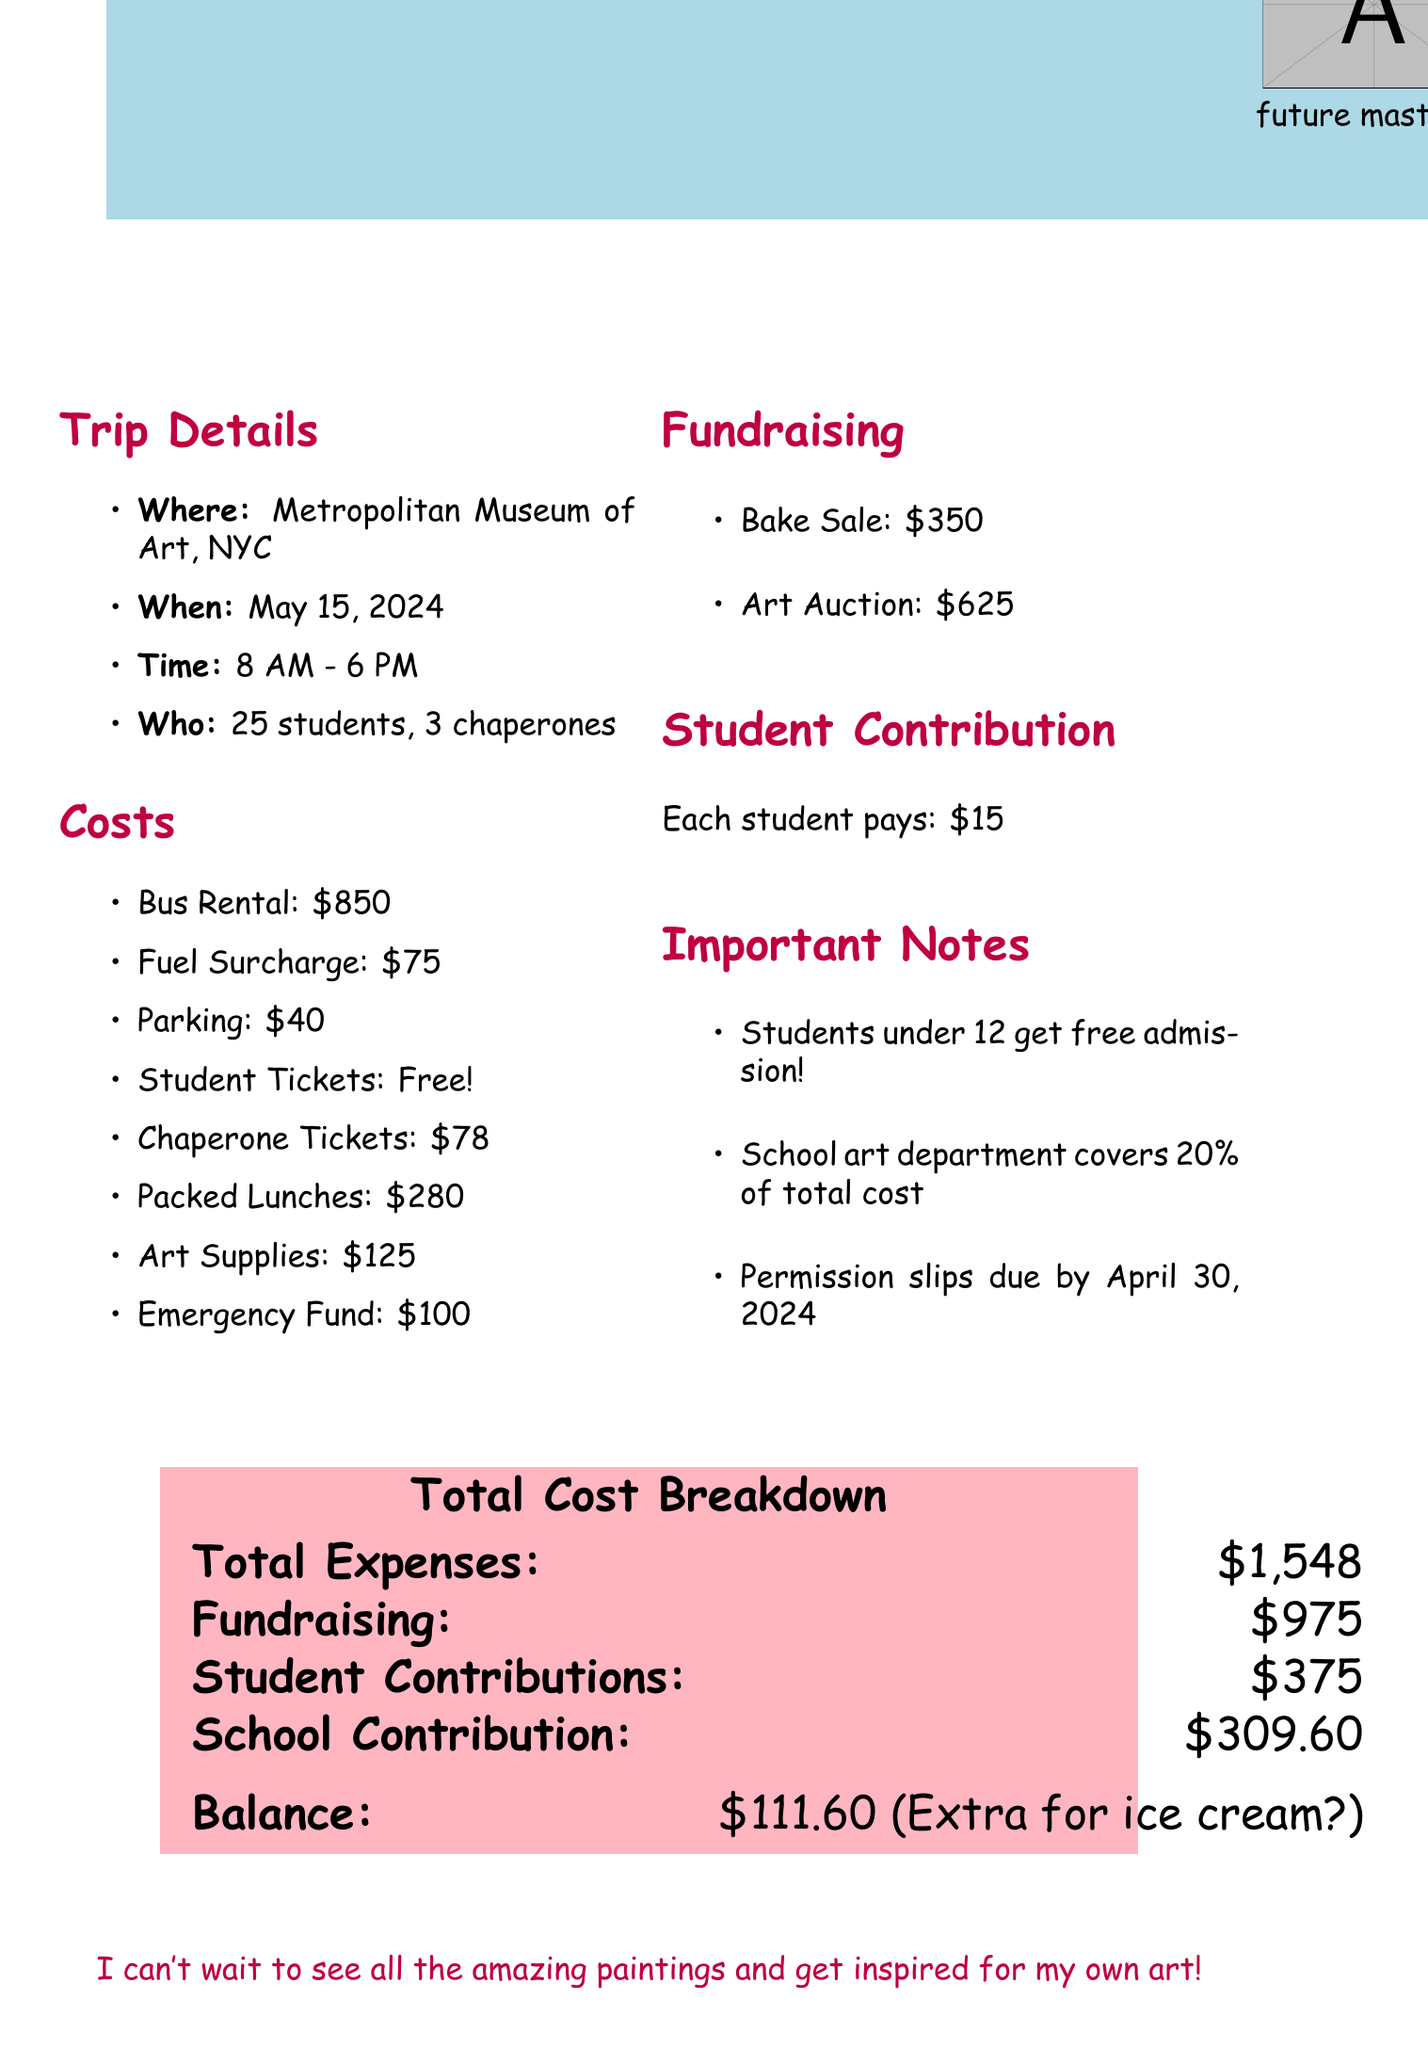What is the destination of the field trip? The document states that the field trip is to the Metropolitan Museum of Art in New York City.
Answer: Metropolitan Museum of Art, New York City When is the field trip scheduled? The date of the field trip is specified as May 15, 2024.
Answer: May 15, 2024 How many students are attending the trip? The document mentions that 25 students will be going on the field trip.
Answer: 25 What is the total cost of packed lunches? The total cost for packed lunches is listed as $280.
Answer: $280 How much money will the school art department cover? The document notes that the school's art department will cover 20% of the total cost.
Answer: 20% What is the total cost breakdown? The document specifies the total expenses calculated in the breakdown as $1,548.
Answer: $1,548 What is the per-student contribution amount? The document states that each student contributes $15 toward the trip.
Answer: $15 What fundraising activity raised the most money? According to the document, the art auction raised the most at $625.
Answer: Art Auction What is the deadline for permission slips? The document indicates that permission slips are due by April 30, 2024.
Answer: April 30, 2024 